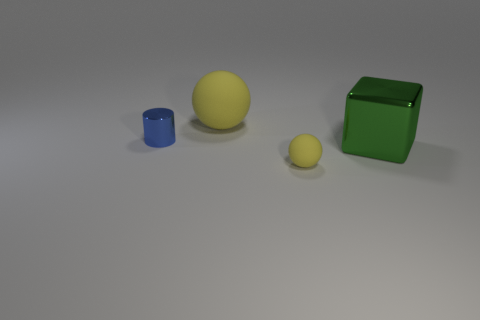Add 3 small yellow objects. How many objects exist? 7 Subtract all blocks. How many objects are left? 3 Subtract all green spheres. Subtract all yellow cubes. How many spheres are left? 2 Subtract all small blue shiny things. Subtract all small yellow rubber things. How many objects are left? 2 Add 3 large things. How many large things are left? 5 Add 4 rubber objects. How many rubber objects exist? 6 Subtract 1 blue cylinders. How many objects are left? 3 